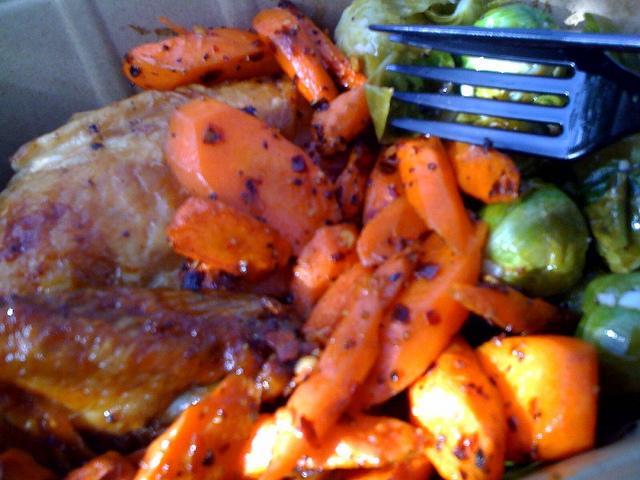Is this meal healthy?
Quick response, please. Yes. What color are the veggies?
Be succinct. Orange and green. Are these vegetables cooked?
Concise answer only. Yes. 